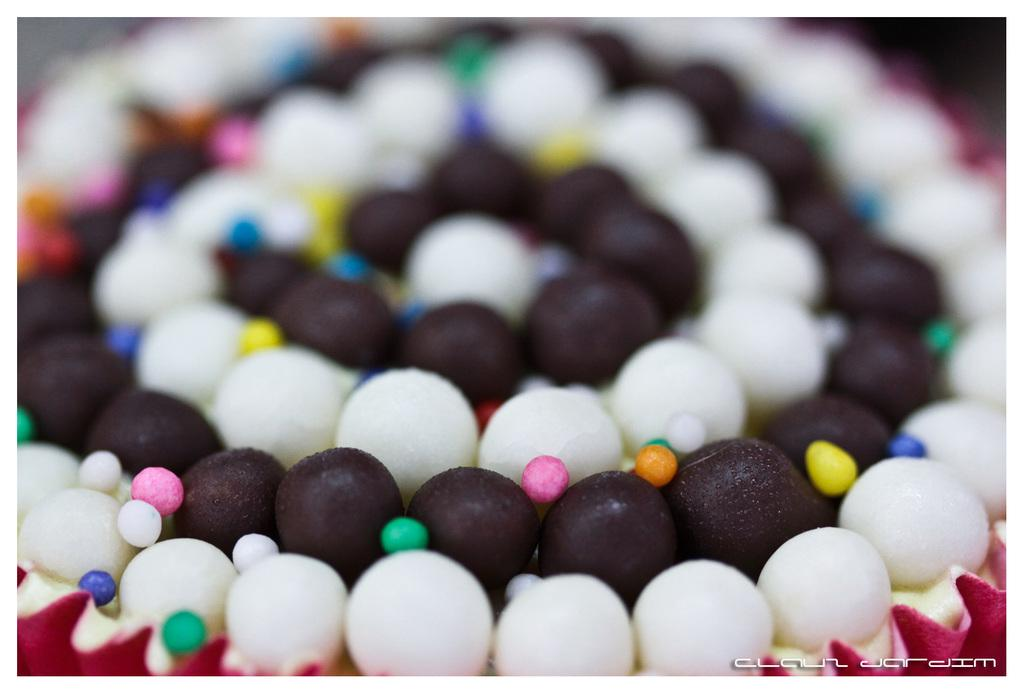What type of food item is visible in the image? There is a food item in the image, but the specific type cannot be determined from the provided facts. What are the brown and white balls in the image? The brown and white balls in the image are not described in detail, so their exact nature cannot be determined. What can be said about the colored balls in the image? A: The colored balls in the image are not described in detail, so their exact nature cannot be determined. What language is being spoken by the engine in the image? There is no engine present in the image, and therefore no language being spoken by it. 